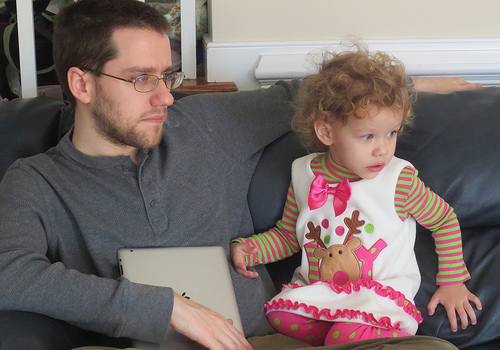<image>
Can you confirm if the child girl is on the man? Yes. Looking at the image, I can see the child girl is positioned on top of the man, with the man providing support. Is there a girl next to the reindeer? No. The girl is not positioned next to the reindeer. They are located in different areas of the scene. Is there a man in front of the girl? No. The man is not in front of the girl. The spatial positioning shows a different relationship between these objects. 